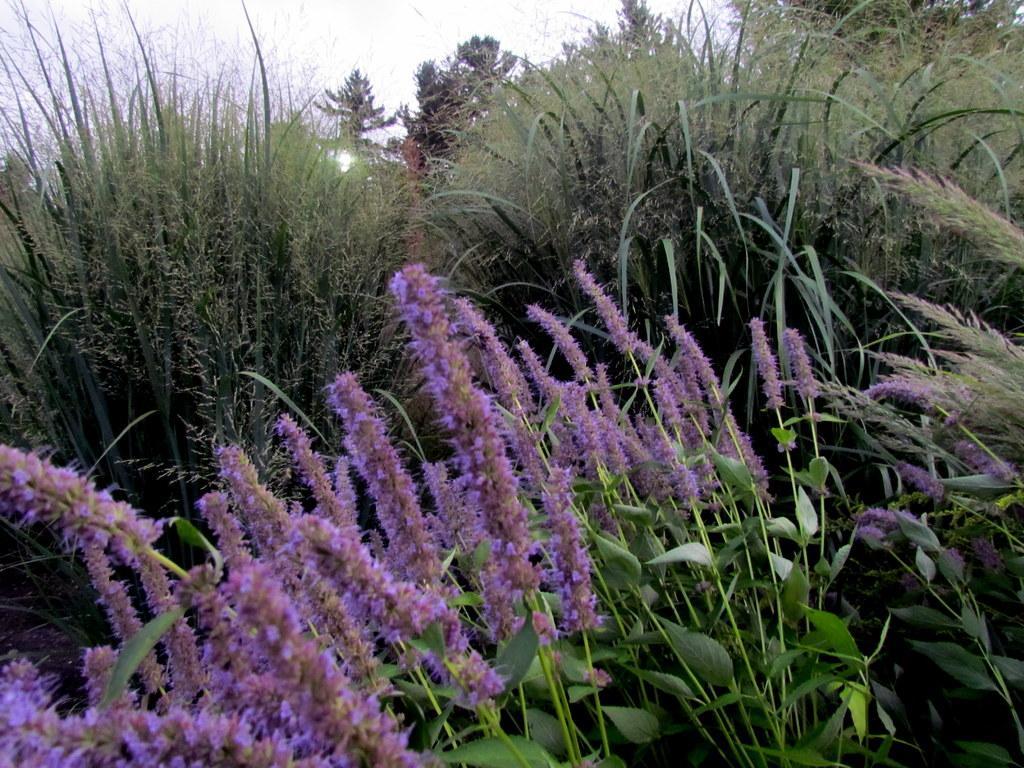Please provide a concise description of this image. In the center of the image there are flower plants. In the background of the image there is sky. 